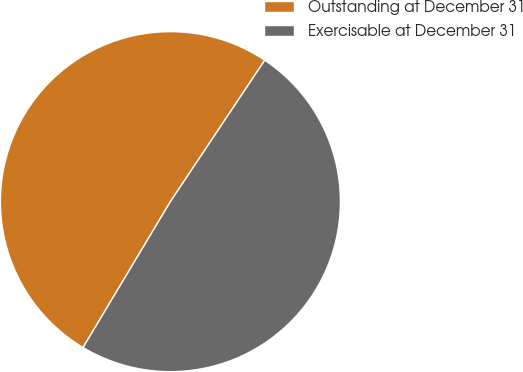Convert chart to OTSL. <chart><loc_0><loc_0><loc_500><loc_500><pie_chart><fcel>Outstanding at December 31<fcel>Exercisable at December 31<nl><fcel>50.78%<fcel>49.22%<nl></chart> 